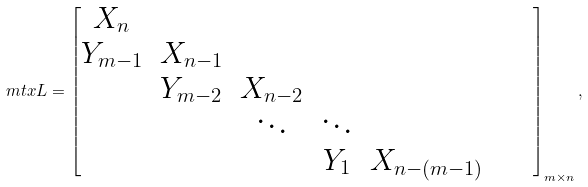<formula> <loc_0><loc_0><loc_500><loc_500>\ m t x { L } = \begin{bmatrix} X _ { n } \\ Y _ { m - 1 } & X _ { n - 1 } \\ & Y _ { m - 2 } & X _ { n - 2 } \\ & & \ddots & \ddots \\ & & & Y _ { 1 } & X _ { n - ( m - 1 ) } & & & \end{bmatrix} _ { m \times n } ,</formula> 